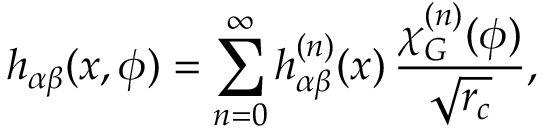<formula> <loc_0><loc_0><loc_500><loc_500>h _ { \alpha \beta } ( x , \phi ) = \sum _ { n = 0 } ^ { \infty } h _ { \alpha \beta } ^ { ( n ) } ( x ) \, \frac { \chi _ { G } ^ { ( n ) } ( \phi ) } { \sqrt { r _ { c } } } ,</formula> 